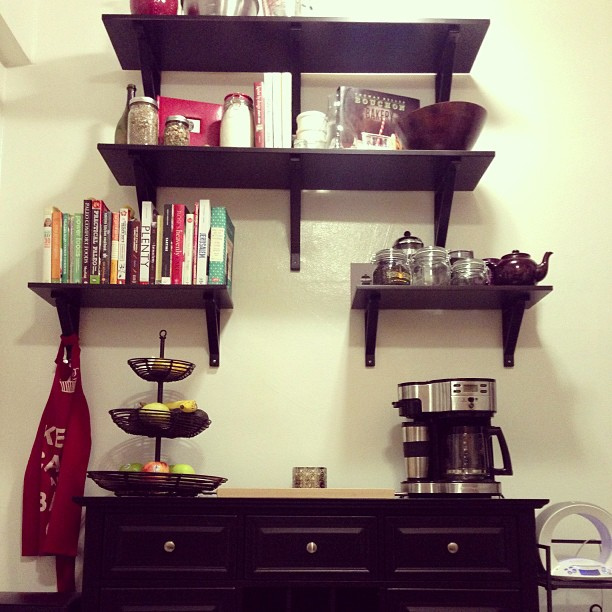Please identify all text content in this image. PLENTY 3 KE 